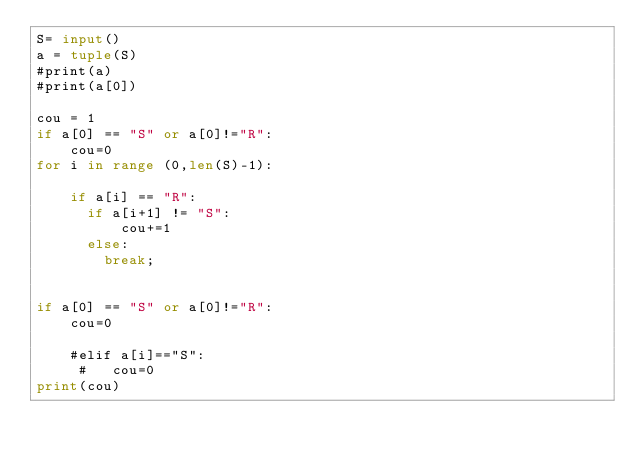<code> <loc_0><loc_0><loc_500><loc_500><_Python_>S= input()
a = tuple(S)
#print(a)
#print(a[0])

cou = 1
if a[0] == "S" or a[0]!="R":
    cou=0
for i in range (0,len(S)-1):
    
    if a[i] == "R":
      if a[i+1] != "S":
          cou+=1
      else:
        break;
          
    
if a[0] == "S" or a[0]!="R":
    cou=0

    #elif a[i]=="S":
     #   cou=0
print(cou)
</code> 